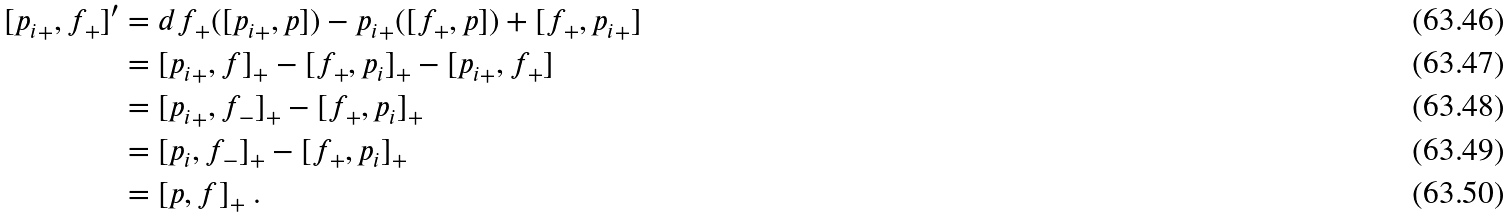Convert formula to latex. <formula><loc_0><loc_0><loc_500><loc_500>[ { p _ { i } } _ { + } , f _ { + } ] ^ { \prime } & = d f _ { + } ( [ { p _ { i } } _ { + } , p ] ) - { p _ { i } } _ { + } ( [ f _ { + } , p ] ) + [ f _ { + } , { p _ { i } } _ { + } ] \\ & = [ { p _ { i } } _ { + } , f ] _ { + } - [ f _ { + } , { p _ { i } } ] _ { + } - [ { p _ { i } } _ { + } , f _ { + } ] \\ & = [ { p _ { i } } _ { + } , f _ { - } ] _ { + } - [ f _ { + } , { p _ { i } } ] _ { + } \\ & = [ { p _ { i } } , f _ { - } ] _ { + } - [ f _ { + } , { p _ { i } } ] _ { + } \\ & = [ p , f ] _ { + } \ .</formula> 